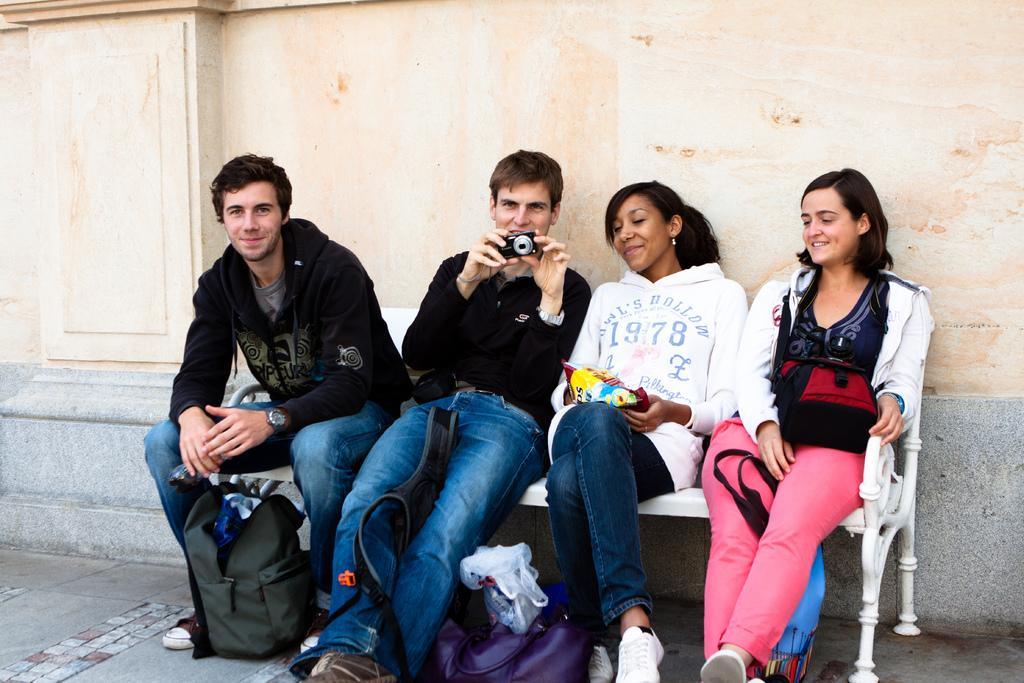How would you summarize this image in a sentence or two? In this image I can see four people sitting on the bench. I can see these people are wearing the different color dresses and one person holding the camera. I can see the bags in-front of these people. And there is a wall in the back 